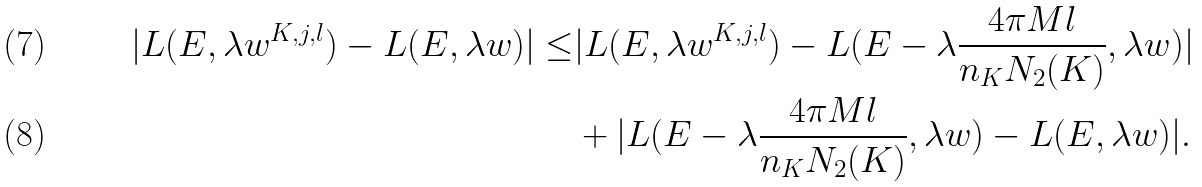<formula> <loc_0><loc_0><loc_500><loc_500>| L ( E , \lambda w ^ { K , j , l } ) - L ( E , \lambda w ) | \leq & | L ( E , \lambda w ^ { K , j , l } ) - L ( E - \lambda \frac { 4 \pi M l } { n _ { K } N _ { 2 } ( K ) } , \lambda w ) | \\ & + | L ( E - \lambda \frac { 4 \pi M l } { n _ { K } N _ { 2 } ( K ) } , \lambda w ) - L ( E , \lambda w ) | .</formula> 